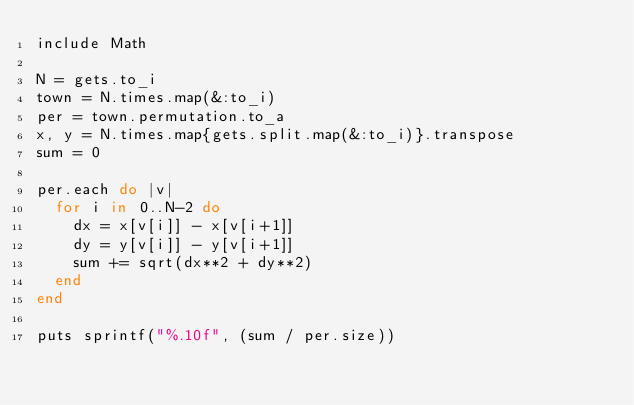Convert code to text. <code><loc_0><loc_0><loc_500><loc_500><_Ruby_>include Math

N = gets.to_i
town = N.times.map(&:to_i)
per = town.permutation.to_a
x, y = N.times.map{gets.split.map(&:to_i)}.transpose
sum = 0

per.each do |v|
  for i in 0..N-2 do
    dx = x[v[i]] - x[v[i+1]]
    dy = y[v[i]] - y[v[i+1]]
    sum += sqrt(dx**2 + dy**2)
  end
end

puts sprintf("%.10f", (sum / per.size))</code> 